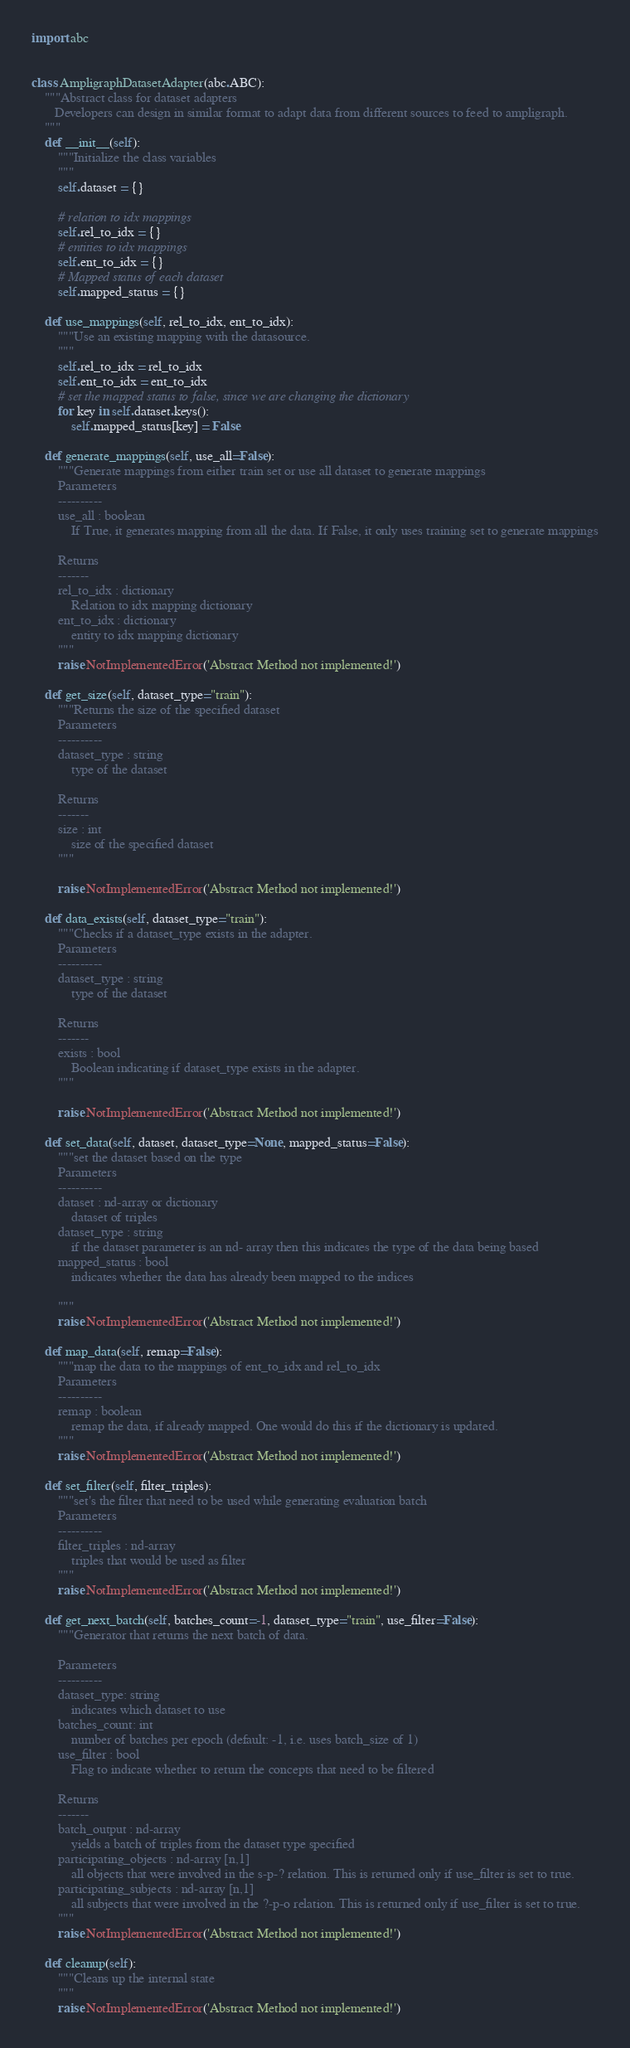Convert code to text. <code><loc_0><loc_0><loc_500><loc_500><_Python_>import abc


class AmpligraphDatasetAdapter(abc.ABC):
    """Abstract class for dataset adapters
       Developers can design in similar format to adapt data from different sources to feed to ampligraph.
    """
    def __init__(self):
        """Initialize the class variables
        """
        self.dataset = {}

        # relation to idx mappings
        self.rel_to_idx = {}
        # entities to idx mappings
        self.ent_to_idx = {}
        # Mapped status of each dataset
        self.mapped_status = {}

    def use_mappings(self, rel_to_idx, ent_to_idx):
        """Use an existing mapping with the datasource.
        """
        self.rel_to_idx = rel_to_idx
        self.ent_to_idx = ent_to_idx
        # set the mapped status to false, since we are changing the dictionary
        for key in self.dataset.keys():
            self.mapped_status[key] = False

    def generate_mappings(self, use_all=False):
        """Generate mappings from either train set or use all dataset to generate mappings
        Parameters
        ----------
        use_all : boolean
            If True, it generates mapping from all the data. If False, it only uses training set to generate mappings

        Returns
        -------
        rel_to_idx : dictionary
            Relation to idx mapping dictionary
        ent_to_idx : dictionary
            entity to idx mapping dictionary
        """
        raise NotImplementedError('Abstract Method not implemented!')

    def get_size(self, dataset_type="train"):
        """Returns the size of the specified dataset
        Parameters
        ----------
        dataset_type : string
            type of the dataset

        Returns
        -------
        size : int
            size of the specified dataset
        """

        raise NotImplementedError('Abstract Method not implemented!')

    def data_exists(self, dataset_type="train"):
        """Checks if a dataset_type exists in the adapter.
        Parameters
        ----------
        dataset_type : string
            type of the dataset

        Returns
        -------
        exists : bool
            Boolean indicating if dataset_type exists in the adapter.
        """

        raise NotImplementedError('Abstract Method not implemented!')

    def set_data(self, dataset, dataset_type=None, mapped_status=False):
        """set the dataset based on the type
        Parameters
        ----------
        dataset : nd-array or dictionary
            dataset of triples
        dataset_type : string
            if the dataset parameter is an nd- array then this indicates the type of the data being based
        mapped_status : bool
            indicates whether the data has already been mapped to the indices

        """
        raise NotImplementedError('Abstract Method not implemented!')

    def map_data(self, remap=False):
        """map the data to the mappings of ent_to_idx and rel_to_idx
        Parameters
        ----------
        remap : boolean
            remap the data, if already mapped. One would do this if the dictionary is updated.
        """
        raise NotImplementedError('Abstract Method not implemented!')

    def set_filter(self, filter_triples):
        """set's the filter that need to be used while generating evaluation batch
        Parameters
        ----------
        filter_triples : nd-array
            triples that would be used as filter
        """
        raise NotImplementedError('Abstract Method not implemented!')

    def get_next_batch(self, batches_count=-1, dataset_type="train", use_filter=False):
        """Generator that returns the next batch of data.

        Parameters
        ----------
        dataset_type: string
            indicates which dataset to use
        batches_count: int
            number of batches per epoch (default: -1, i.e. uses batch_size of 1)
        use_filter : bool
            Flag to indicate whether to return the concepts that need to be filtered

        Returns
        -------
        batch_output : nd-array
            yields a batch of triples from the dataset type specified
        participating_objects : nd-array [n,1]
            all objects that were involved in the s-p-? relation. This is returned only if use_filter is set to true.
        participating_subjects : nd-array [n,1]
            all subjects that were involved in the ?-p-o relation. This is returned only if use_filter is set to true.
        """
        raise NotImplementedError('Abstract Method not implemented!')

    def cleanup(self):
        """Cleans up the internal state
        """
        raise NotImplementedError('Abstract Method not implemented!')
</code> 